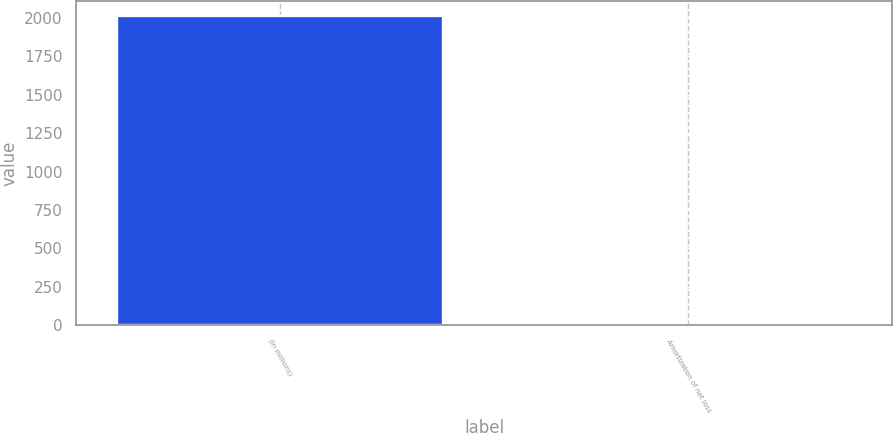<chart> <loc_0><loc_0><loc_500><loc_500><bar_chart><fcel>(in millions)<fcel>Amortization of net loss<nl><fcel>2012<fcel>3<nl></chart> 